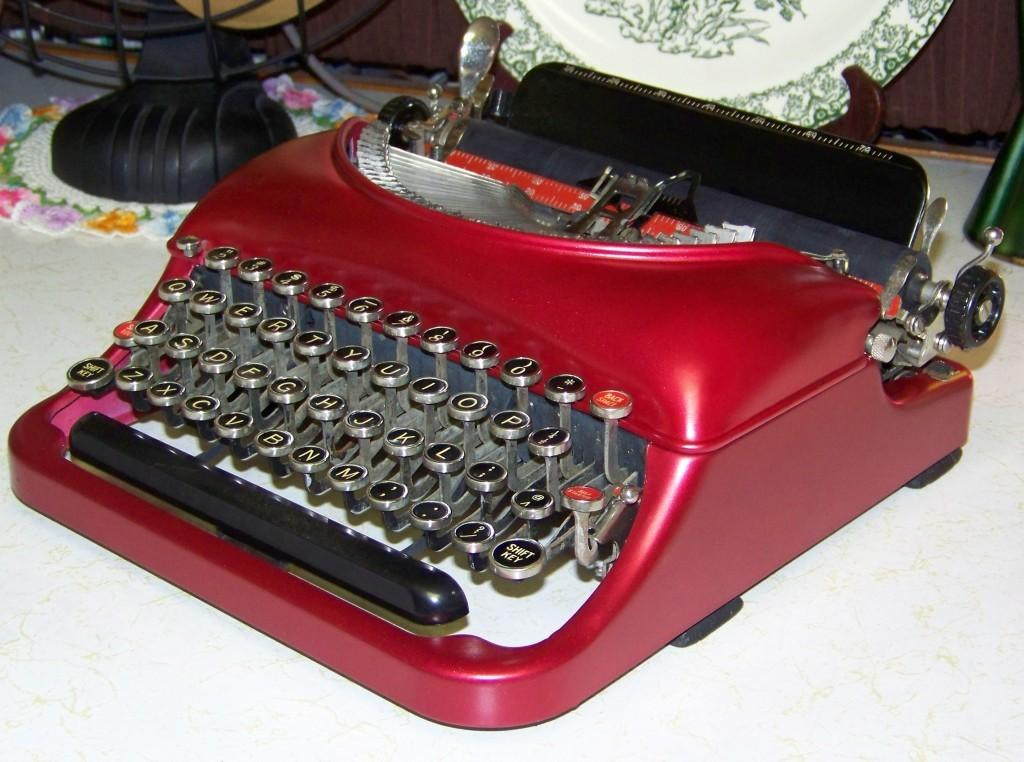What is the main object in the image? There is a typing machine in the image. What colors are used for the typing machine? The typing machine is in red and black color. What other object can be seen in the image? There is a plate in the image. What is the color of the object mentioned? There is a black color object in the image. On what surface are the typing machine, plate, and black color object placed? The typing machine, plate, and black color object are on a white color surface. How many beans are on the plate in the image? There are no beans present on the plate in the image. Are there any ducks or frogs visible in the image? There are no ducks or frogs visible in the image. 